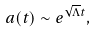<formula> <loc_0><loc_0><loc_500><loc_500>a ( t ) \sim e ^ { \sqrt { \Lambda } t } ,</formula> 